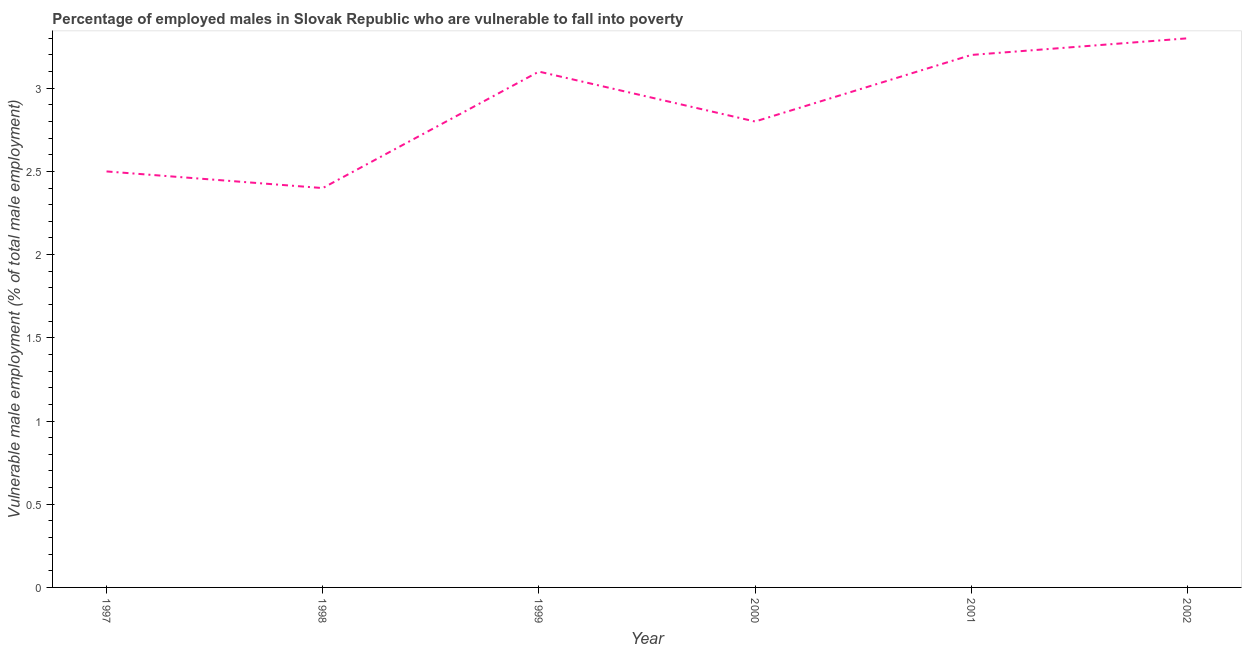What is the percentage of employed males who are vulnerable to fall into poverty in 2001?
Give a very brief answer. 3.2. Across all years, what is the maximum percentage of employed males who are vulnerable to fall into poverty?
Ensure brevity in your answer.  3.3. Across all years, what is the minimum percentage of employed males who are vulnerable to fall into poverty?
Offer a terse response. 2.4. In which year was the percentage of employed males who are vulnerable to fall into poverty minimum?
Make the answer very short. 1998. What is the sum of the percentage of employed males who are vulnerable to fall into poverty?
Your answer should be compact. 17.3. What is the average percentage of employed males who are vulnerable to fall into poverty per year?
Offer a terse response. 2.88. What is the median percentage of employed males who are vulnerable to fall into poverty?
Give a very brief answer. 2.95. In how many years, is the percentage of employed males who are vulnerable to fall into poverty greater than 0.2 %?
Ensure brevity in your answer.  6. What is the ratio of the percentage of employed males who are vulnerable to fall into poverty in 1998 to that in 2002?
Keep it short and to the point. 0.73. Is the difference between the percentage of employed males who are vulnerable to fall into poverty in 1997 and 2001 greater than the difference between any two years?
Your response must be concise. No. What is the difference between the highest and the second highest percentage of employed males who are vulnerable to fall into poverty?
Provide a short and direct response. 0.1. What is the difference between the highest and the lowest percentage of employed males who are vulnerable to fall into poverty?
Offer a terse response. 0.9. In how many years, is the percentage of employed males who are vulnerable to fall into poverty greater than the average percentage of employed males who are vulnerable to fall into poverty taken over all years?
Your answer should be compact. 3. Does the graph contain grids?
Offer a very short reply. No. What is the title of the graph?
Ensure brevity in your answer.  Percentage of employed males in Slovak Republic who are vulnerable to fall into poverty. What is the label or title of the X-axis?
Make the answer very short. Year. What is the label or title of the Y-axis?
Offer a very short reply. Vulnerable male employment (% of total male employment). What is the Vulnerable male employment (% of total male employment) in 1998?
Give a very brief answer. 2.4. What is the Vulnerable male employment (% of total male employment) of 1999?
Give a very brief answer. 3.1. What is the Vulnerable male employment (% of total male employment) of 2000?
Your response must be concise. 2.8. What is the Vulnerable male employment (% of total male employment) of 2001?
Give a very brief answer. 3.2. What is the Vulnerable male employment (% of total male employment) of 2002?
Make the answer very short. 3.3. What is the difference between the Vulnerable male employment (% of total male employment) in 1997 and 1998?
Your answer should be compact. 0.1. What is the difference between the Vulnerable male employment (% of total male employment) in 1997 and 1999?
Offer a terse response. -0.6. What is the difference between the Vulnerable male employment (% of total male employment) in 1997 and 2000?
Provide a succinct answer. -0.3. What is the difference between the Vulnerable male employment (% of total male employment) in 1997 and 2001?
Provide a succinct answer. -0.7. What is the difference between the Vulnerable male employment (% of total male employment) in 1998 and 1999?
Your response must be concise. -0.7. What is the difference between the Vulnerable male employment (% of total male employment) in 1998 and 2000?
Your response must be concise. -0.4. What is the difference between the Vulnerable male employment (% of total male employment) in 1998 and 2001?
Keep it short and to the point. -0.8. What is the difference between the Vulnerable male employment (% of total male employment) in 1998 and 2002?
Make the answer very short. -0.9. What is the difference between the Vulnerable male employment (% of total male employment) in 1999 and 2001?
Make the answer very short. -0.1. What is the difference between the Vulnerable male employment (% of total male employment) in 2000 and 2002?
Provide a short and direct response. -0.5. What is the ratio of the Vulnerable male employment (% of total male employment) in 1997 to that in 1998?
Provide a short and direct response. 1.04. What is the ratio of the Vulnerable male employment (% of total male employment) in 1997 to that in 1999?
Offer a very short reply. 0.81. What is the ratio of the Vulnerable male employment (% of total male employment) in 1997 to that in 2000?
Ensure brevity in your answer.  0.89. What is the ratio of the Vulnerable male employment (% of total male employment) in 1997 to that in 2001?
Offer a very short reply. 0.78. What is the ratio of the Vulnerable male employment (% of total male employment) in 1997 to that in 2002?
Ensure brevity in your answer.  0.76. What is the ratio of the Vulnerable male employment (% of total male employment) in 1998 to that in 1999?
Give a very brief answer. 0.77. What is the ratio of the Vulnerable male employment (% of total male employment) in 1998 to that in 2000?
Your answer should be compact. 0.86. What is the ratio of the Vulnerable male employment (% of total male employment) in 1998 to that in 2001?
Give a very brief answer. 0.75. What is the ratio of the Vulnerable male employment (% of total male employment) in 1998 to that in 2002?
Ensure brevity in your answer.  0.73. What is the ratio of the Vulnerable male employment (% of total male employment) in 1999 to that in 2000?
Your answer should be compact. 1.11. What is the ratio of the Vulnerable male employment (% of total male employment) in 1999 to that in 2002?
Keep it short and to the point. 0.94. What is the ratio of the Vulnerable male employment (% of total male employment) in 2000 to that in 2002?
Your response must be concise. 0.85. 